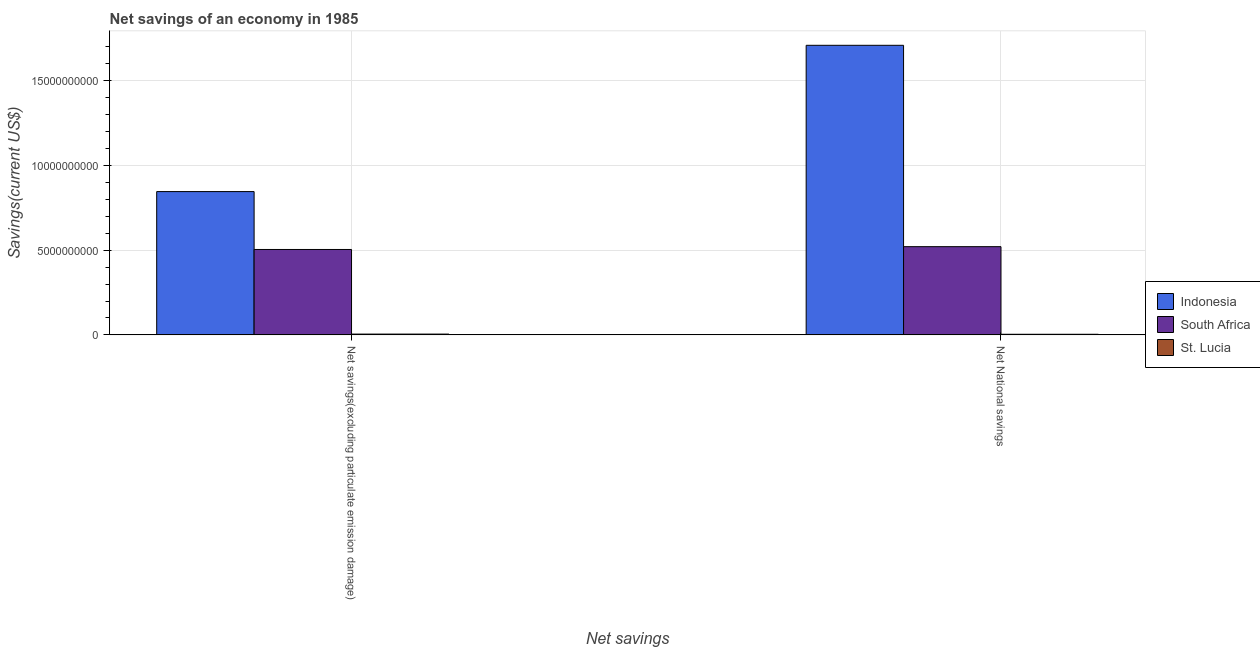Are the number of bars per tick equal to the number of legend labels?
Keep it short and to the point. Yes. Are the number of bars on each tick of the X-axis equal?
Make the answer very short. Yes. How many bars are there on the 1st tick from the left?
Provide a succinct answer. 3. How many bars are there on the 1st tick from the right?
Make the answer very short. 3. What is the label of the 2nd group of bars from the left?
Your answer should be compact. Net National savings. What is the net savings(excluding particulate emission damage) in St. Lucia?
Provide a succinct answer. 4.71e+07. Across all countries, what is the maximum net savings(excluding particulate emission damage)?
Offer a very short reply. 8.46e+09. Across all countries, what is the minimum net savings(excluding particulate emission damage)?
Provide a succinct answer. 4.71e+07. In which country was the net national savings minimum?
Offer a very short reply. St. Lucia. What is the total net national savings in the graph?
Give a very brief answer. 2.23e+1. What is the difference between the net savings(excluding particulate emission damage) in South Africa and that in Indonesia?
Your response must be concise. -3.42e+09. What is the difference between the net savings(excluding particulate emission damage) in South Africa and the net national savings in St. Lucia?
Make the answer very short. 5.01e+09. What is the average net national savings per country?
Provide a succinct answer. 7.45e+09. What is the difference between the net national savings and net savings(excluding particulate emission damage) in South Africa?
Give a very brief answer. 1.67e+08. In how many countries, is the net national savings greater than 12000000000 US$?
Your answer should be very brief. 1. What is the ratio of the net savings(excluding particulate emission damage) in South Africa to that in Indonesia?
Offer a very short reply. 0.6. In how many countries, is the net savings(excluding particulate emission damage) greater than the average net savings(excluding particulate emission damage) taken over all countries?
Provide a short and direct response. 2. What does the 3rd bar from the left in Net savings(excluding particulate emission damage) represents?
Provide a succinct answer. St. Lucia. What does the 2nd bar from the right in Net National savings represents?
Provide a succinct answer. South Africa. How many bars are there?
Your answer should be compact. 6. Are all the bars in the graph horizontal?
Offer a terse response. No. Are the values on the major ticks of Y-axis written in scientific E-notation?
Provide a short and direct response. No. Does the graph contain any zero values?
Give a very brief answer. No. Does the graph contain grids?
Offer a very short reply. Yes. What is the title of the graph?
Your answer should be very brief. Net savings of an economy in 1985. What is the label or title of the X-axis?
Provide a succinct answer. Net savings. What is the label or title of the Y-axis?
Your response must be concise. Savings(current US$). What is the Savings(current US$) in Indonesia in Net savings(excluding particulate emission damage)?
Ensure brevity in your answer.  8.46e+09. What is the Savings(current US$) of South Africa in Net savings(excluding particulate emission damage)?
Ensure brevity in your answer.  5.04e+09. What is the Savings(current US$) of St. Lucia in Net savings(excluding particulate emission damage)?
Provide a short and direct response. 4.71e+07. What is the Savings(current US$) of Indonesia in Net National savings?
Make the answer very short. 1.71e+1. What is the Savings(current US$) in South Africa in Net National savings?
Your answer should be compact. 5.21e+09. What is the Savings(current US$) in St. Lucia in Net National savings?
Your response must be concise. 3.65e+07. Across all Net savings, what is the maximum Savings(current US$) of Indonesia?
Make the answer very short. 1.71e+1. Across all Net savings, what is the maximum Savings(current US$) of South Africa?
Provide a succinct answer. 5.21e+09. Across all Net savings, what is the maximum Savings(current US$) in St. Lucia?
Give a very brief answer. 4.71e+07. Across all Net savings, what is the minimum Savings(current US$) of Indonesia?
Keep it short and to the point. 8.46e+09. Across all Net savings, what is the minimum Savings(current US$) in South Africa?
Your answer should be compact. 5.04e+09. Across all Net savings, what is the minimum Savings(current US$) of St. Lucia?
Ensure brevity in your answer.  3.65e+07. What is the total Savings(current US$) of Indonesia in the graph?
Your response must be concise. 2.56e+1. What is the total Savings(current US$) of South Africa in the graph?
Keep it short and to the point. 1.03e+1. What is the total Savings(current US$) of St. Lucia in the graph?
Your answer should be compact. 8.37e+07. What is the difference between the Savings(current US$) in Indonesia in Net savings(excluding particulate emission damage) and that in Net National savings?
Give a very brief answer. -8.64e+09. What is the difference between the Savings(current US$) in South Africa in Net savings(excluding particulate emission damage) and that in Net National savings?
Give a very brief answer. -1.67e+08. What is the difference between the Savings(current US$) in St. Lucia in Net savings(excluding particulate emission damage) and that in Net National savings?
Your answer should be very brief. 1.06e+07. What is the difference between the Savings(current US$) in Indonesia in Net savings(excluding particulate emission damage) and the Savings(current US$) in South Africa in Net National savings?
Give a very brief answer. 3.25e+09. What is the difference between the Savings(current US$) of Indonesia in Net savings(excluding particulate emission damage) and the Savings(current US$) of St. Lucia in Net National savings?
Ensure brevity in your answer.  8.42e+09. What is the difference between the Savings(current US$) of South Africa in Net savings(excluding particulate emission damage) and the Savings(current US$) of St. Lucia in Net National savings?
Your response must be concise. 5.01e+09. What is the average Savings(current US$) in Indonesia per Net savings?
Provide a short and direct response. 1.28e+1. What is the average Savings(current US$) in South Africa per Net savings?
Provide a short and direct response. 5.13e+09. What is the average Savings(current US$) in St. Lucia per Net savings?
Provide a short and direct response. 4.18e+07. What is the difference between the Savings(current US$) of Indonesia and Savings(current US$) of South Africa in Net savings(excluding particulate emission damage)?
Provide a short and direct response. 3.42e+09. What is the difference between the Savings(current US$) in Indonesia and Savings(current US$) in St. Lucia in Net savings(excluding particulate emission damage)?
Offer a very short reply. 8.41e+09. What is the difference between the Savings(current US$) of South Africa and Savings(current US$) of St. Lucia in Net savings(excluding particulate emission damage)?
Your answer should be compact. 4.99e+09. What is the difference between the Savings(current US$) in Indonesia and Savings(current US$) in South Africa in Net National savings?
Offer a terse response. 1.19e+1. What is the difference between the Savings(current US$) of Indonesia and Savings(current US$) of St. Lucia in Net National savings?
Offer a terse response. 1.71e+1. What is the difference between the Savings(current US$) of South Africa and Savings(current US$) of St. Lucia in Net National savings?
Offer a terse response. 5.17e+09. What is the ratio of the Savings(current US$) in Indonesia in Net savings(excluding particulate emission damage) to that in Net National savings?
Offer a terse response. 0.49. What is the ratio of the Savings(current US$) of St. Lucia in Net savings(excluding particulate emission damage) to that in Net National savings?
Provide a succinct answer. 1.29. What is the difference between the highest and the second highest Savings(current US$) in Indonesia?
Offer a terse response. 8.64e+09. What is the difference between the highest and the second highest Savings(current US$) in South Africa?
Provide a succinct answer. 1.67e+08. What is the difference between the highest and the second highest Savings(current US$) in St. Lucia?
Your response must be concise. 1.06e+07. What is the difference between the highest and the lowest Savings(current US$) of Indonesia?
Provide a succinct answer. 8.64e+09. What is the difference between the highest and the lowest Savings(current US$) of South Africa?
Offer a very short reply. 1.67e+08. What is the difference between the highest and the lowest Savings(current US$) of St. Lucia?
Ensure brevity in your answer.  1.06e+07. 